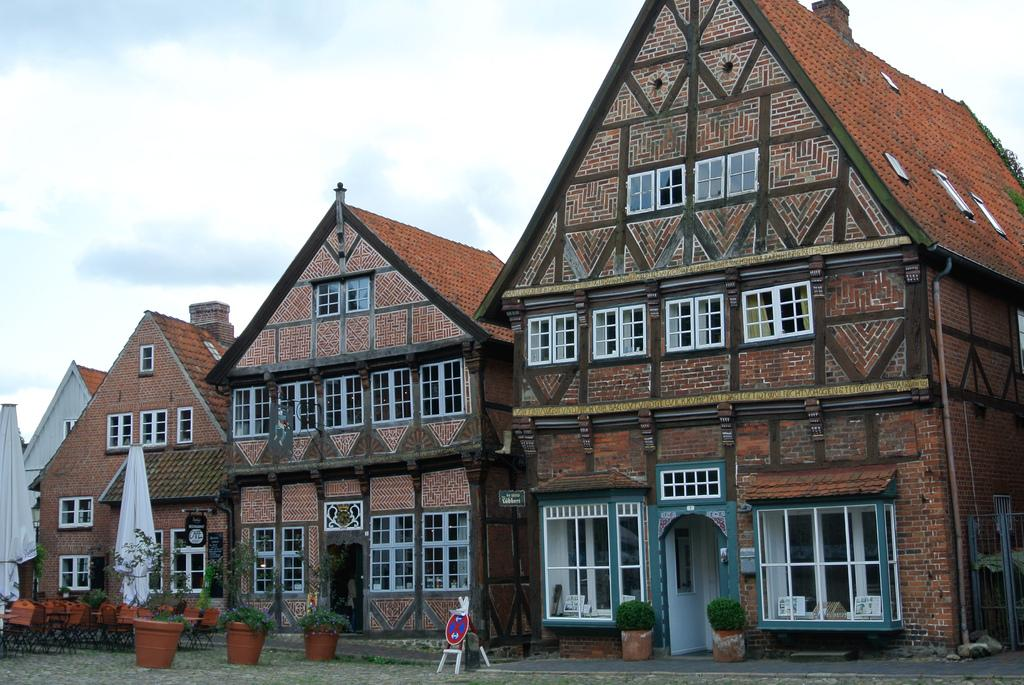How many buildings can be seen in the image? There are three buildings in the image. What features do the buildings have? The buildings have windows and doors. Are there any plants visible near the buildings? Yes, there are house plants near the buildings. What can be seen in the background of the image? There is a sky visible in the background of the image, and clouds are present in the sky. What color are the eyes of the person standing in front of the buildings? There are no people, including those with eyes, present in the image. 